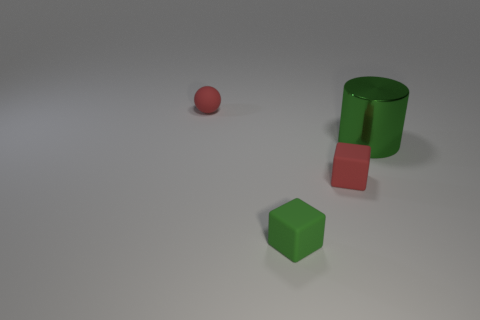How many other things are the same color as the metallic cylinder? 1 